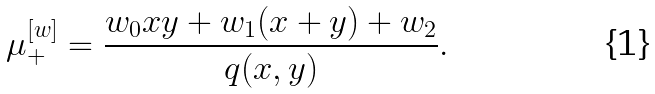Convert formula to latex. <formula><loc_0><loc_0><loc_500><loc_500>\mu _ { + } ^ { [ w ] } = \frac { w _ { 0 } x y + w _ { 1 } ( x + y ) + w _ { 2 } } { q ( x , y ) } .</formula> 